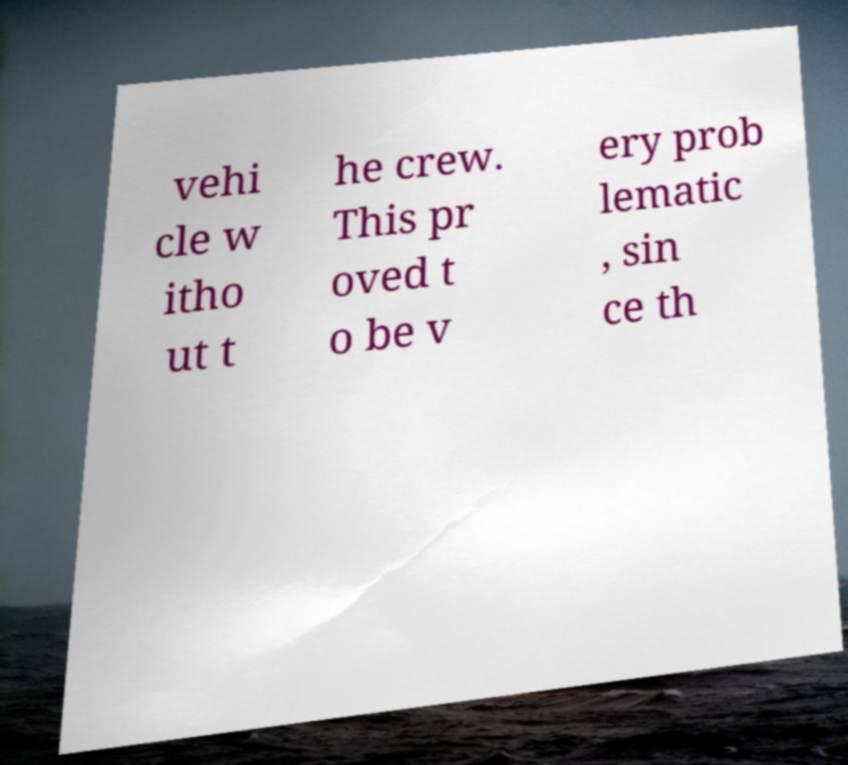For documentation purposes, I need the text within this image transcribed. Could you provide that? vehi cle w itho ut t he crew. This pr oved t o be v ery prob lematic , sin ce th 